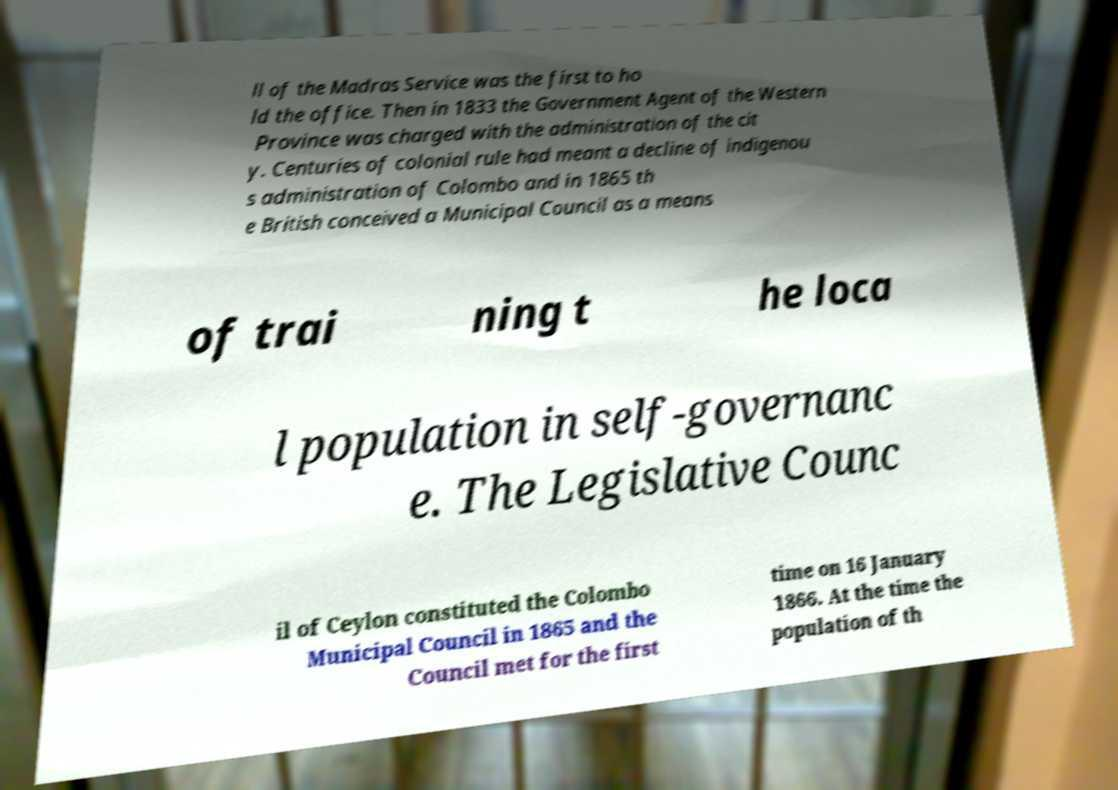For documentation purposes, I need the text within this image transcribed. Could you provide that? ll of the Madras Service was the first to ho ld the office. Then in 1833 the Government Agent of the Western Province was charged with the administration of the cit y. Centuries of colonial rule had meant a decline of indigenou s administration of Colombo and in 1865 th e British conceived a Municipal Council as a means of trai ning t he loca l population in self-governanc e. The Legislative Counc il of Ceylon constituted the Colombo Municipal Council in 1865 and the Council met for the first time on 16 January 1866. At the time the population of th 